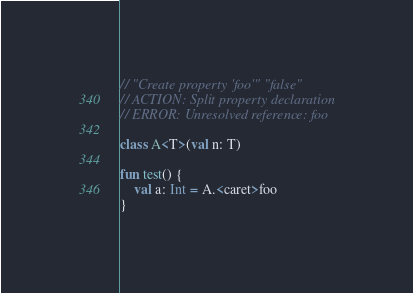Convert code to text. <code><loc_0><loc_0><loc_500><loc_500><_Kotlin_>// "Create property 'foo'" "false"
// ACTION: Split property declaration
// ERROR: Unresolved reference: foo

class A<T>(val n: T)

fun test() {
    val a: Int = A.<caret>foo
}
</code> 